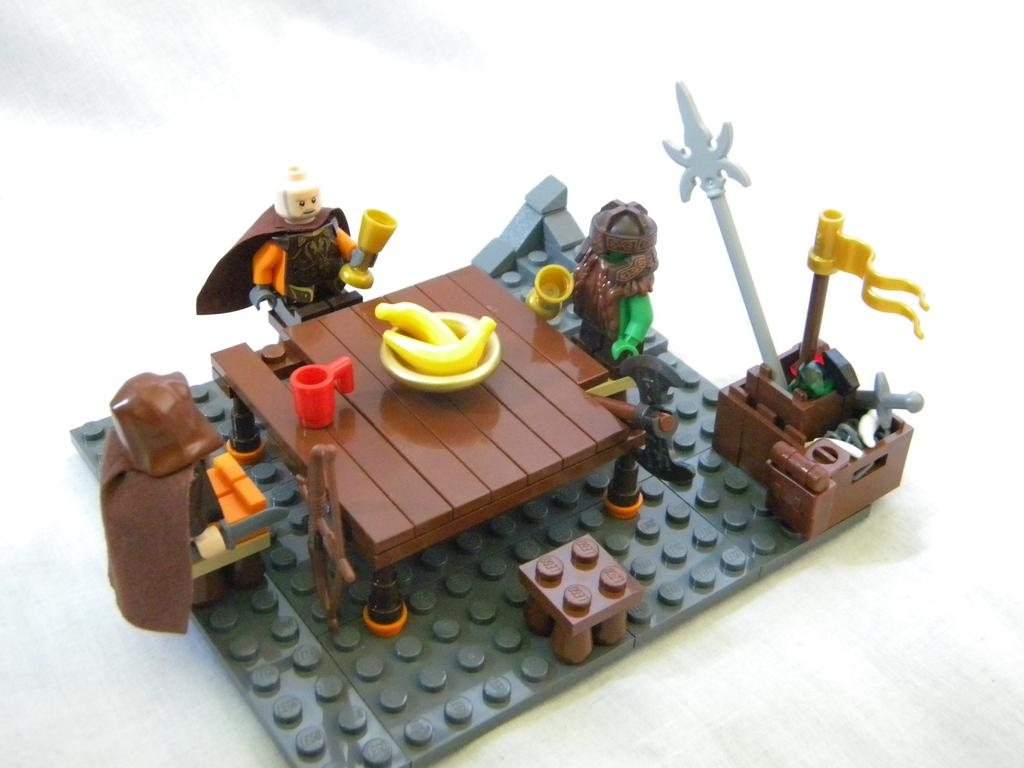What objects are present in the image? There are toys and building blocks in the image. How are the toys arranged? The toys are on building blocks. What is the color of the surface the toys and building blocks are on? The surface is white. Where are the toys, building blocks, and white surface located in the image? They are in the middle of the image. What type of pear is being polished by the parent in the image? There is no pear or parent present in the image; it only features toys, building blocks, and a white surface. 